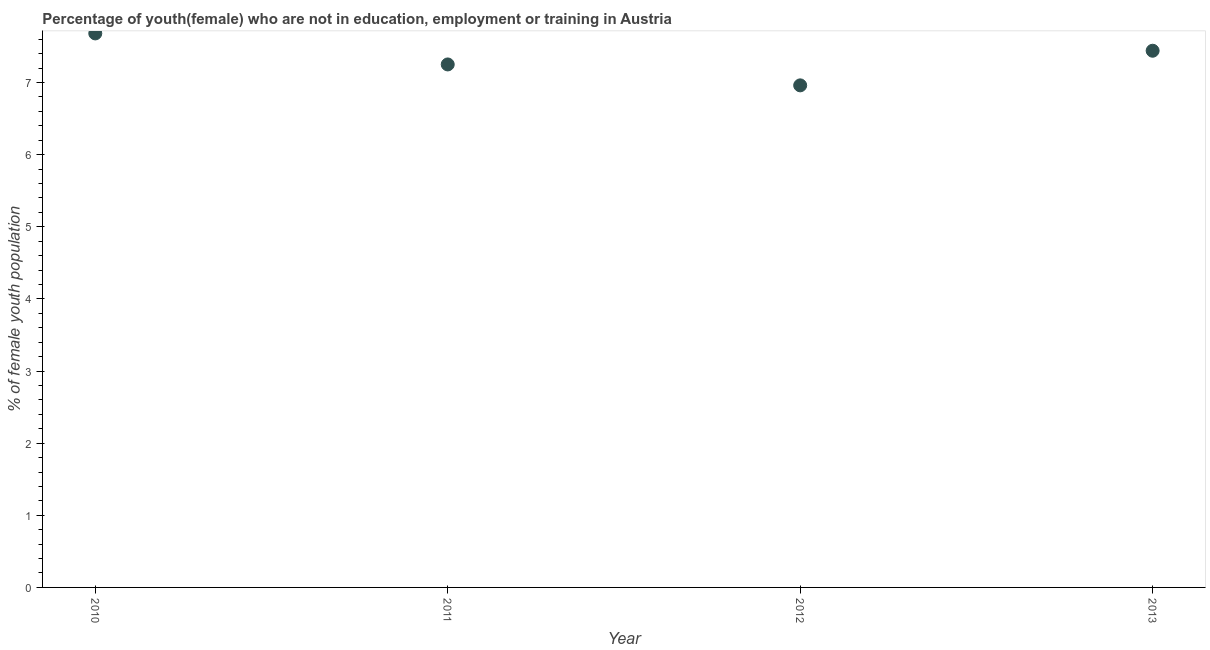What is the unemployed female youth population in 2011?
Keep it short and to the point. 7.25. Across all years, what is the maximum unemployed female youth population?
Offer a terse response. 7.68. Across all years, what is the minimum unemployed female youth population?
Keep it short and to the point. 6.96. In which year was the unemployed female youth population maximum?
Give a very brief answer. 2010. In which year was the unemployed female youth population minimum?
Give a very brief answer. 2012. What is the sum of the unemployed female youth population?
Keep it short and to the point. 29.33. What is the difference between the unemployed female youth population in 2011 and 2012?
Make the answer very short. 0.29. What is the average unemployed female youth population per year?
Give a very brief answer. 7.33. What is the median unemployed female youth population?
Your answer should be very brief. 7.35. Do a majority of the years between 2013 and 2010 (inclusive) have unemployed female youth population greater than 3.4 %?
Offer a very short reply. Yes. What is the ratio of the unemployed female youth population in 2010 to that in 2013?
Provide a short and direct response. 1.03. What is the difference between the highest and the second highest unemployed female youth population?
Your response must be concise. 0.24. What is the difference between the highest and the lowest unemployed female youth population?
Provide a short and direct response. 0.72. How many years are there in the graph?
Your answer should be very brief. 4. What is the difference between two consecutive major ticks on the Y-axis?
Provide a short and direct response. 1. Does the graph contain any zero values?
Your response must be concise. No. What is the title of the graph?
Your answer should be compact. Percentage of youth(female) who are not in education, employment or training in Austria. What is the label or title of the Y-axis?
Your answer should be compact. % of female youth population. What is the % of female youth population in 2010?
Provide a succinct answer. 7.68. What is the % of female youth population in 2011?
Your response must be concise. 7.25. What is the % of female youth population in 2012?
Offer a terse response. 6.96. What is the % of female youth population in 2013?
Make the answer very short. 7.44. What is the difference between the % of female youth population in 2010 and 2011?
Your answer should be very brief. 0.43. What is the difference between the % of female youth population in 2010 and 2012?
Your response must be concise. 0.72. What is the difference between the % of female youth population in 2010 and 2013?
Provide a succinct answer. 0.24. What is the difference between the % of female youth population in 2011 and 2012?
Give a very brief answer. 0.29. What is the difference between the % of female youth population in 2011 and 2013?
Ensure brevity in your answer.  -0.19. What is the difference between the % of female youth population in 2012 and 2013?
Make the answer very short. -0.48. What is the ratio of the % of female youth population in 2010 to that in 2011?
Your answer should be compact. 1.06. What is the ratio of the % of female youth population in 2010 to that in 2012?
Offer a very short reply. 1.1. What is the ratio of the % of female youth population in 2010 to that in 2013?
Ensure brevity in your answer.  1.03. What is the ratio of the % of female youth population in 2011 to that in 2012?
Offer a very short reply. 1.04. What is the ratio of the % of female youth population in 2012 to that in 2013?
Make the answer very short. 0.94. 